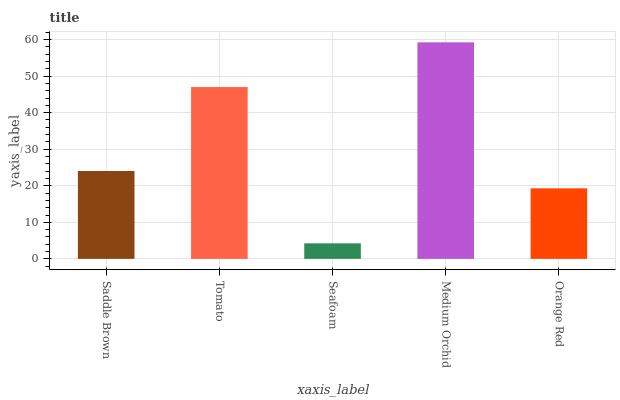Is Seafoam the minimum?
Answer yes or no. Yes. Is Medium Orchid the maximum?
Answer yes or no. Yes. Is Tomato the minimum?
Answer yes or no. No. Is Tomato the maximum?
Answer yes or no. No. Is Tomato greater than Saddle Brown?
Answer yes or no. Yes. Is Saddle Brown less than Tomato?
Answer yes or no. Yes. Is Saddle Brown greater than Tomato?
Answer yes or no. No. Is Tomato less than Saddle Brown?
Answer yes or no. No. Is Saddle Brown the high median?
Answer yes or no. Yes. Is Saddle Brown the low median?
Answer yes or no. Yes. Is Medium Orchid the high median?
Answer yes or no. No. Is Seafoam the low median?
Answer yes or no. No. 